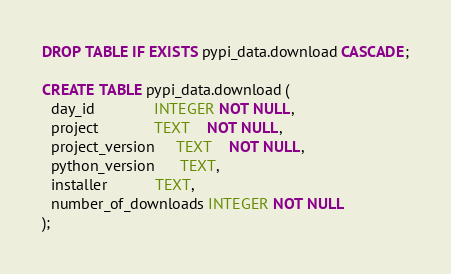Convert code to text. <code><loc_0><loc_0><loc_500><loc_500><_SQL_>DROP TABLE IF EXISTS pypi_data.download CASCADE;

CREATE TABLE pypi_data.download (
  day_id              INTEGER NOT NULL,
  project             TEXT    NOT NULL,
  project_version     TEXT    NOT NULL,
  python_version      TEXT,
  installer           TEXT,
  number_of_downloads INTEGER NOT NULL
);

</code> 